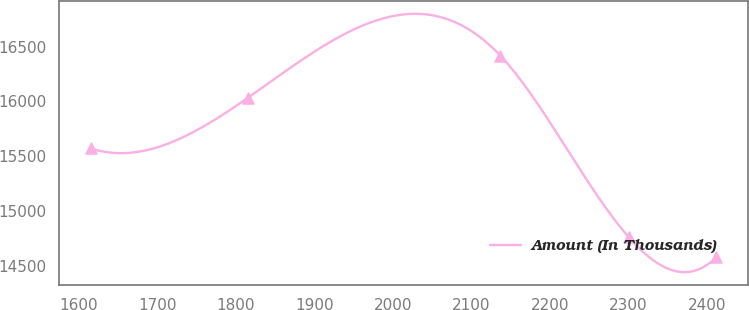Convert chart to OTSL. <chart><loc_0><loc_0><loc_500><loc_500><line_chart><ecel><fcel>Amount (In Thousands)<nl><fcel>1615.12<fcel>15570.8<nl><fcel>1815.38<fcel>16032.5<nl><fcel>2137.09<fcel>16416.7<nl><fcel>2300.45<fcel>14762.8<nl><fcel>2412.42<fcel>14579.1<nl></chart> 